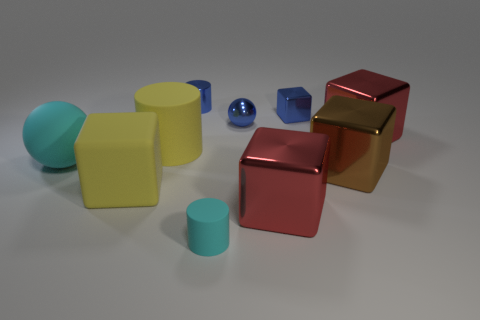How many yellow shiny balls are the same size as the blue shiny cube?
Ensure brevity in your answer.  0. There is a cylinder that is both behind the cyan ball and in front of the tiny sphere; what is its material?
Keep it short and to the point. Rubber. There is a yellow rubber cylinder; what number of things are left of it?
Provide a short and direct response. 2. There is a brown shiny object; does it have the same shape as the cyan thing that is left of the blue shiny cylinder?
Ensure brevity in your answer.  No. Are there any yellow objects that have the same shape as the large brown thing?
Your answer should be very brief. Yes. What shape is the yellow object in front of the big yellow rubber thing behind the large rubber sphere?
Offer a terse response. Cube. There is a cyan object to the left of the blue cylinder; what is its shape?
Offer a terse response. Sphere. Does the tiny metal object on the right side of the tiny blue ball have the same color as the sphere that is to the left of the tiny sphere?
Your response must be concise. No. What number of objects are both on the right side of the yellow block and left of the small cyan rubber object?
Offer a terse response. 2. There is a sphere that is the same material as the small cyan cylinder; what is its size?
Give a very brief answer. Large. 